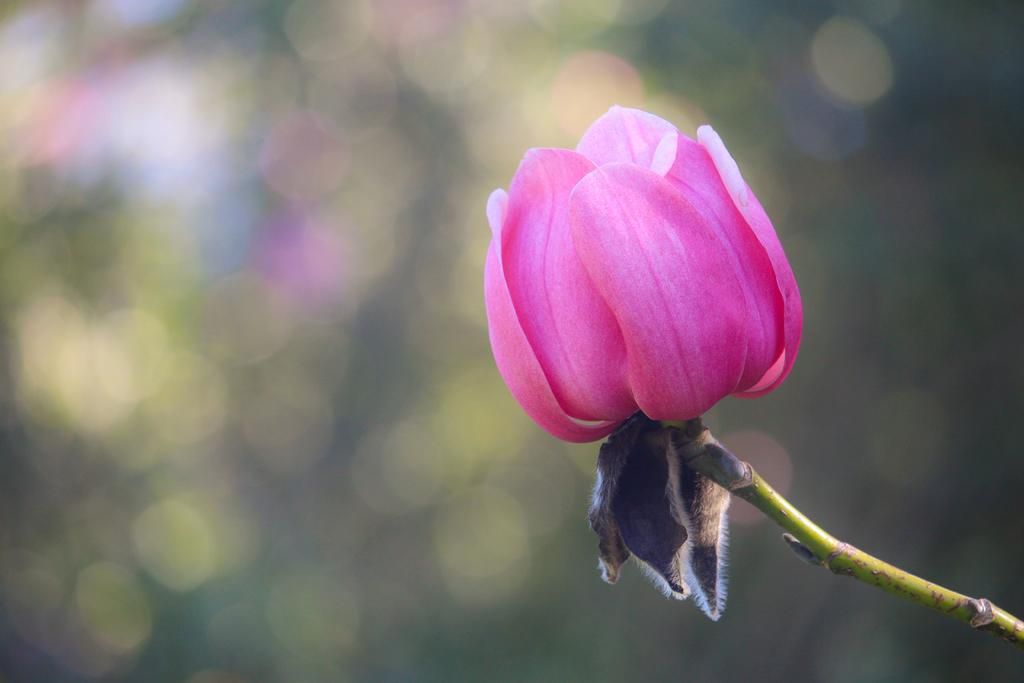What is the main subject of the image? There is a flower in the image. What color is the flower? The flower is pink. Can you describe the background of the image? The background of the image is blurred. What type of robin can be seen perched on the edge of the flower in the image? There is no robin present in the image; it only features a pink flower with a blurred background. 